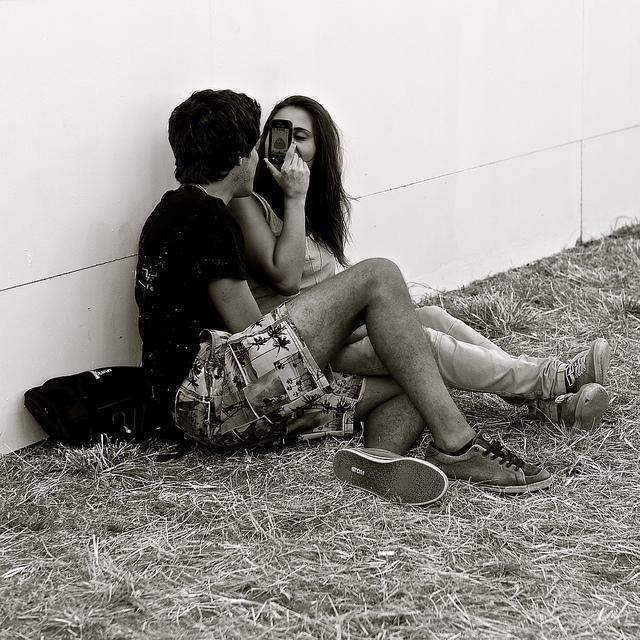How many people are shown?
Give a very brief answer. 2. How many people are there?
Give a very brief answer. 2. 